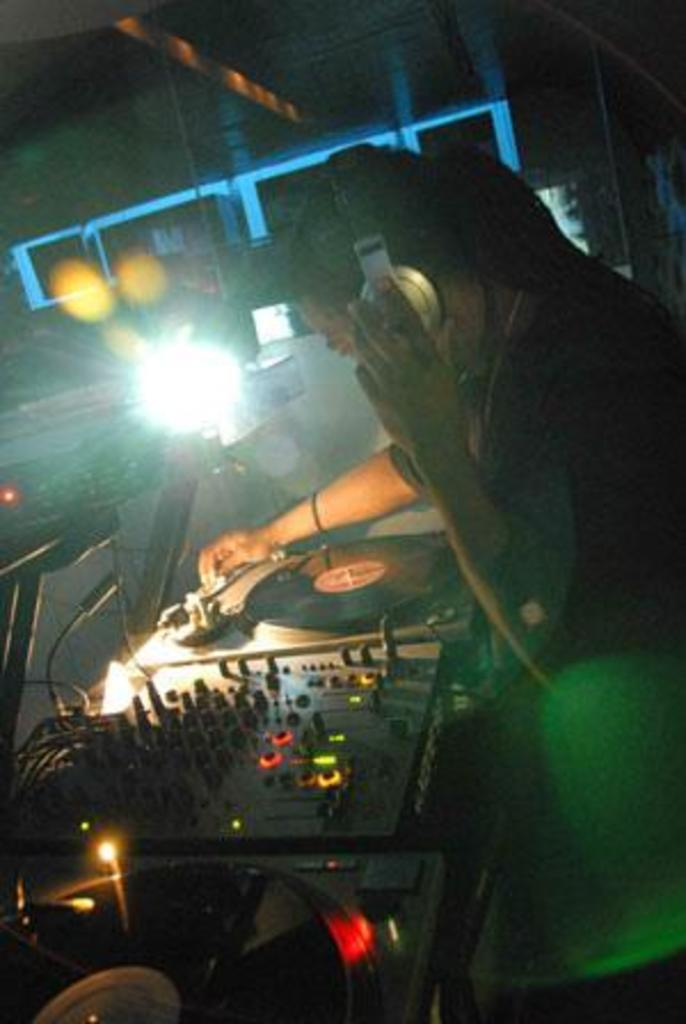Who is present in the image? There is a man in the image. What is the man wearing on his head? The man is wearing a headset. What objects are in front of the man? There are musical instruments in front of the man. What can be seen in the background of the image? There are lights visible in the background of the image. Can you see any deer in the image? No, there are no deer present in the image. Is the man standing on a stage in the image? The provided facts do not mention a stage, so it cannot be confirmed or denied. 